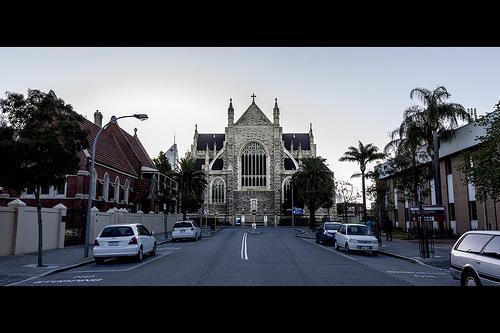How many churches are there?
Give a very brief answer. 1. 